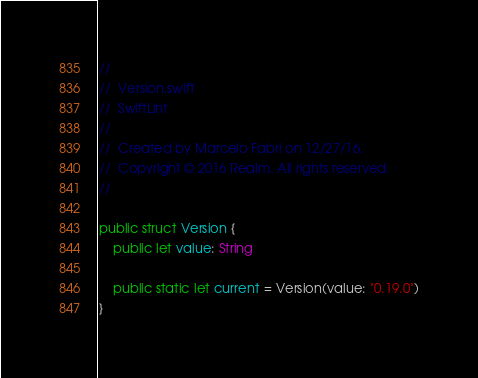<code> <loc_0><loc_0><loc_500><loc_500><_Swift_>//
//  Version.swift
//  SwiftLint
//
//  Created by Marcelo Fabri on 12/27/16.
//  Copyright © 2016 Realm. All rights reserved.
//

public struct Version {
    public let value: String

    public static let current = Version(value: "0.19.0")
}
</code> 